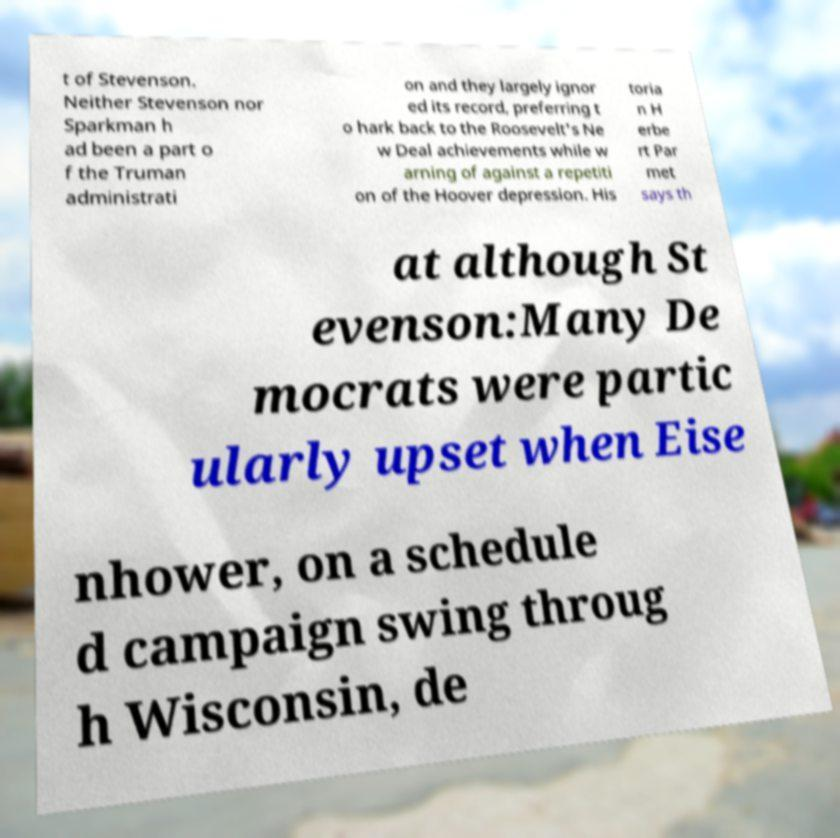Please read and relay the text visible in this image. What does it say? t of Stevenson. Neither Stevenson nor Sparkman h ad been a part o f the Truman administrati on and they largely ignor ed its record, preferring t o hark back to the Roosevelt's Ne w Deal achievements while w arning of against a repetiti on of the Hoover depression. His toria n H erbe rt Par met says th at although St evenson:Many De mocrats were partic ularly upset when Eise nhower, on a schedule d campaign swing throug h Wisconsin, de 